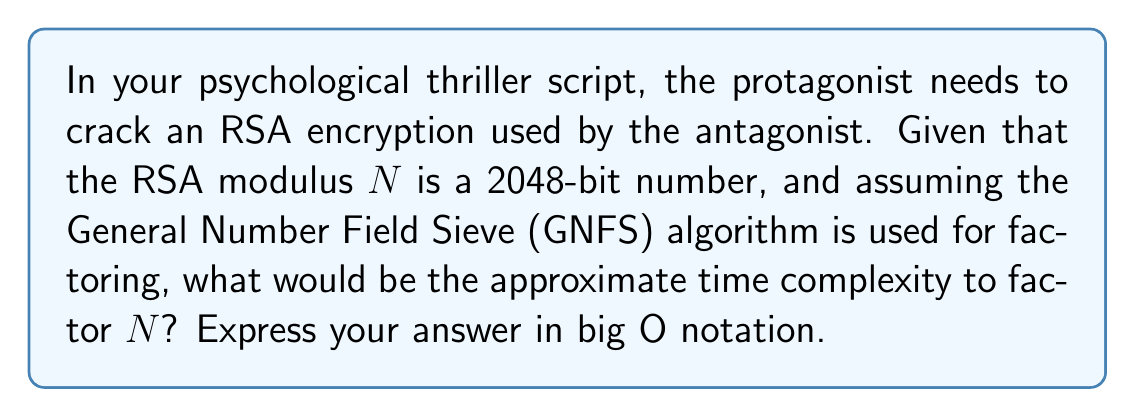Could you help me with this problem? To determine the time complexity of factoring large prime numbers for RSA encryption, we need to consider the following steps:

1. The RSA modulus $N$ is a product of two large prime numbers, typically of equal bit length.

2. The General Number Field Sieve (GNFS) is currently the most efficient known algorithm for factoring large integers.

3. The time complexity of GNFS is given by:

   $$O(\exp((c + o(1))(\ln N)^{1/3}(\ln \ln N)^{2/3}))$$

   where $c$ is a constant approximately equal to $(64/9)^{1/3} \approx 1.923$.

4. For a 2048-bit RSA modulus, $N \approx 2^{2048}$.

5. Substituting this into the GNFS time complexity formula:

   $$O(\exp((1.923 + o(1))(\ln 2^{2048})^{1/3}(\ln \ln 2^{2048})^{2/3}))$$

6. Simplify:
   $$O(\exp((1.923 + o(1))(2048 \ln 2)^{1/3}(\ln(2048 \ln 2))^{2/3}))$$

7. This can be further approximated as:

   $$O(\exp((\ln N)^{1/3}(\ln \ln N)^{2/3}))$$

This expression represents the time complexity of factoring a 2048-bit RSA modulus using the GNFS algorithm.
Answer: $O(\exp((\ln N)^{1/3}(\ln \ln N)^{2/3}))$ 